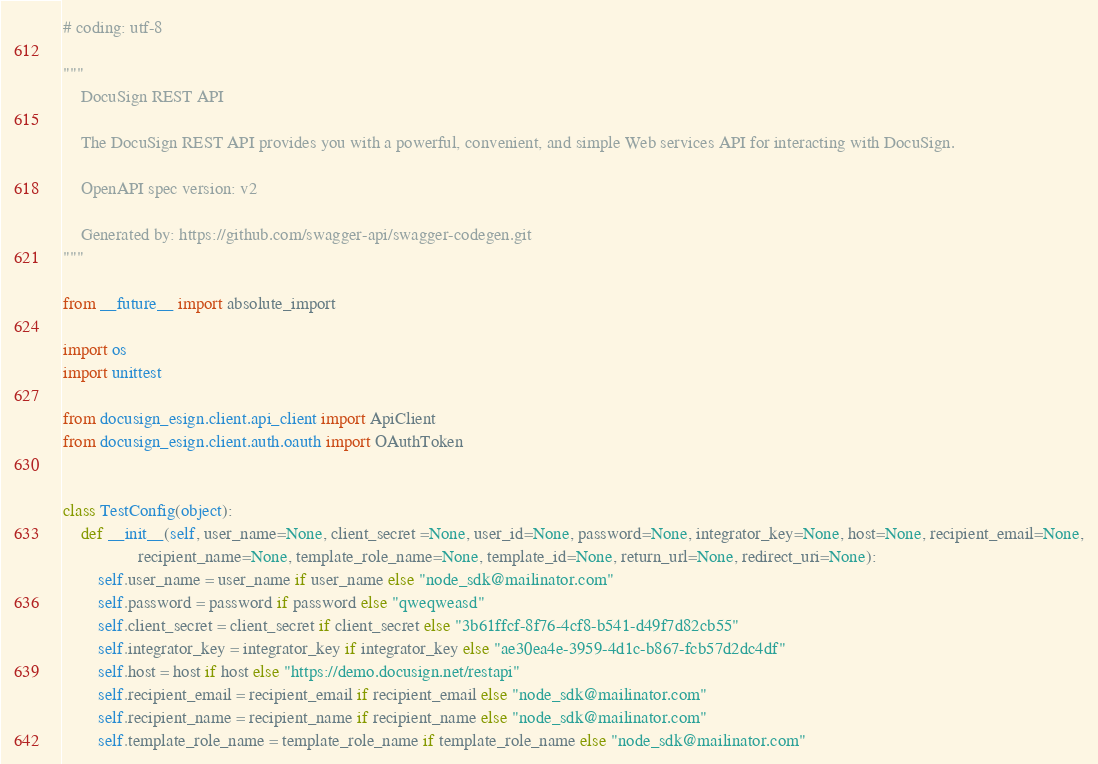<code> <loc_0><loc_0><loc_500><loc_500><_Python_># coding: utf-8

"""
    DocuSign REST API

    The DocuSign REST API provides you with a powerful, convenient, and simple Web services API for interacting with DocuSign.

    OpenAPI spec version: v2

    Generated by: https://github.com/swagger-api/swagger-codegen.git
"""

from __future__ import absolute_import

import os
import unittest

from docusign_esign.client.api_client import ApiClient
from docusign_esign.client.auth.oauth import OAuthToken


class TestConfig(object):
    def __init__(self, user_name=None, client_secret =None, user_id=None, password=None, integrator_key=None, host=None, recipient_email=None,
                 recipient_name=None, template_role_name=None, template_id=None, return_url=None, redirect_uri=None):
        self.user_name = user_name if user_name else "node_sdk@mailinator.com"
        self.password = password if password else "qweqweasd"
        self.client_secret = client_secret if client_secret else "3b61ffcf-8f76-4cf8-b541-d49f7d82cb55"
        self.integrator_key = integrator_key if integrator_key else "ae30ea4e-3959-4d1c-b867-fcb57d2dc4df"
        self.host = host if host else "https://demo.docusign.net/restapi"
        self.recipient_email = recipient_email if recipient_email else "node_sdk@mailinator.com"
        self.recipient_name = recipient_name if recipient_name else "node_sdk@mailinator.com"
        self.template_role_name = template_role_name if template_role_name else "node_sdk@mailinator.com"</code> 